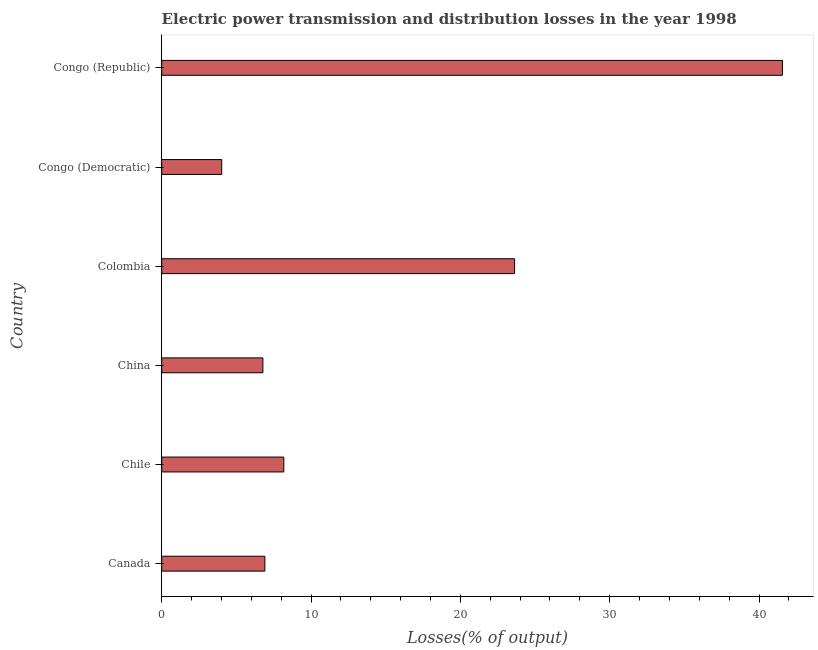Does the graph contain any zero values?
Provide a short and direct response. No. What is the title of the graph?
Offer a very short reply. Electric power transmission and distribution losses in the year 1998. What is the label or title of the X-axis?
Provide a short and direct response. Losses(% of output). What is the label or title of the Y-axis?
Your answer should be very brief. Country. What is the electric power transmission and distribution losses in Colombia?
Offer a very short reply. 23.63. Across all countries, what is the maximum electric power transmission and distribution losses?
Offer a terse response. 41.57. Across all countries, what is the minimum electric power transmission and distribution losses?
Your response must be concise. 4.02. In which country was the electric power transmission and distribution losses maximum?
Provide a succinct answer. Congo (Republic). In which country was the electric power transmission and distribution losses minimum?
Offer a very short reply. Congo (Democratic). What is the sum of the electric power transmission and distribution losses?
Your answer should be very brief. 91.08. What is the difference between the electric power transmission and distribution losses in Canada and Congo (Republic)?
Ensure brevity in your answer.  -34.66. What is the average electric power transmission and distribution losses per country?
Offer a very short reply. 15.18. What is the median electric power transmission and distribution losses?
Your answer should be very brief. 7.54. In how many countries, is the electric power transmission and distribution losses greater than 22 %?
Give a very brief answer. 2. What is the ratio of the electric power transmission and distribution losses in Colombia to that in Congo (Republic)?
Your answer should be very brief. 0.57. Is the electric power transmission and distribution losses in Chile less than that in Colombia?
Ensure brevity in your answer.  Yes. Is the difference between the electric power transmission and distribution losses in China and Colombia greater than the difference between any two countries?
Your answer should be very brief. No. What is the difference between the highest and the second highest electric power transmission and distribution losses?
Provide a succinct answer. 17.94. Is the sum of the electric power transmission and distribution losses in Canada and Chile greater than the maximum electric power transmission and distribution losses across all countries?
Your response must be concise. No. What is the difference between the highest and the lowest electric power transmission and distribution losses?
Give a very brief answer. 37.55. How many countries are there in the graph?
Provide a short and direct response. 6. What is the Losses(% of output) of Canada?
Give a very brief answer. 6.91. What is the Losses(% of output) of Chile?
Your answer should be very brief. 8.18. What is the Losses(% of output) in China?
Ensure brevity in your answer.  6.78. What is the Losses(% of output) in Colombia?
Provide a succinct answer. 23.63. What is the Losses(% of output) of Congo (Democratic)?
Give a very brief answer. 4.02. What is the Losses(% of output) of Congo (Republic)?
Provide a short and direct response. 41.57. What is the difference between the Losses(% of output) in Canada and Chile?
Your answer should be compact. -1.27. What is the difference between the Losses(% of output) in Canada and China?
Make the answer very short. 0.13. What is the difference between the Losses(% of output) in Canada and Colombia?
Offer a very short reply. -16.72. What is the difference between the Losses(% of output) in Canada and Congo (Democratic)?
Your answer should be very brief. 2.89. What is the difference between the Losses(% of output) in Canada and Congo (Republic)?
Make the answer very short. -34.66. What is the difference between the Losses(% of output) in Chile and China?
Provide a succinct answer. 1.4. What is the difference between the Losses(% of output) in Chile and Colombia?
Keep it short and to the point. -15.46. What is the difference between the Losses(% of output) in Chile and Congo (Democratic)?
Provide a succinct answer. 4.16. What is the difference between the Losses(% of output) in Chile and Congo (Republic)?
Offer a terse response. -33.39. What is the difference between the Losses(% of output) in China and Colombia?
Keep it short and to the point. -16.86. What is the difference between the Losses(% of output) in China and Congo (Democratic)?
Your answer should be compact. 2.76. What is the difference between the Losses(% of output) in China and Congo (Republic)?
Offer a terse response. -34.79. What is the difference between the Losses(% of output) in Colombia and Congo (Democratic)?
Provide a short and direct response. 19.61. What is the difference between the Losses(% of output) in Colombia and Congo (Republic)?
Give a very brief answer. -17.94. What is the difference between the Losses(% of output) in Congo (Democratic) and Congo (Republic)?
Give a very brief answer. -37.55. What is the ratio of the Losses(% of output) in Canada to that in Chile?
Give a very brief answer. 0.84. What is the ratio of the Losses(% of output) in Canada to that in China?
Your answer should be compact. 1.02. What is the ratio of the Losses(% of output) in Canada to that in Colombia?
Give a very brief answer. 0.29. What is the ratio of the Losses(% of output) in Canada to that in Congo (Democratic)?
Provide a succinct answer. 1.72. What is the ratio of the Losses(% of output) in Canada to that in Congo (Republic)?
Make the answer very short. 0.17. What is the ratio of the Losses(% of output) in Chile to that in China?
Your answer should be compact. 1.21. What is the ratio of the Losses(% of output) in Chile to that in Colombia?
Provide a short and direct response. 0.35. What is the ratio of the Losses(% of output) in Chile to that in Congo (Democratic)?
Your answer should be very brief. 2.03. What is the ratio of the Losses(% of output) in Chile to that in Congo (Republic)?
Give a very brief answer. 0.2. What is the ratio of the Losses(% of output) in China to that in Colombia?
Your response must be concise. 0.29. What is the ratio of the Losses(% of output) in China to that in Congo (Democratic)?
Keep it short and to the point. 1.69. What is the ratio of the Losses(% of output) in China to that in Congo (Republic)?
Ensure brevity in your answer.  0.16. What is the ratio of the Losses(% of output) in Colombia to that in Congo (Democratic)?
Provide a succinct answer. 5.88. What is the ratio of the Losses(% of output) in Colombia to that in Congo (Republic)?
Make the answer very short. 0.57. What is the ratio of the Losses(% of output) in Congo (Democratic) to that in Congo (Republic)?
Provide a succinct answer. 0.1. 